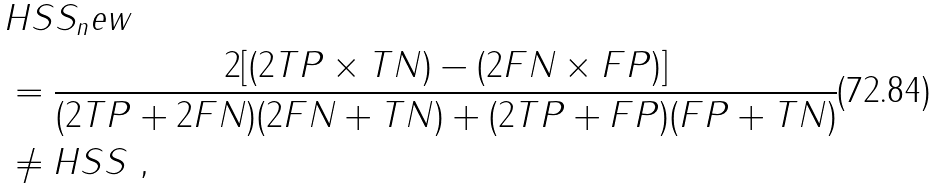<formula> <loc_0><loc_0><loc_500><loc_500>& H S S _ { n } e w \\ & = \frac { 2 [ ( 2 T P \times T N ) - ( 2 F N \times F P ) ] } { ( 2 T P + 2 F N ) ( 2 F N + T N ) + ( 2 T P + F P ) ( F P + T N ) } \\ & \neq H S S \ ,</formula> 